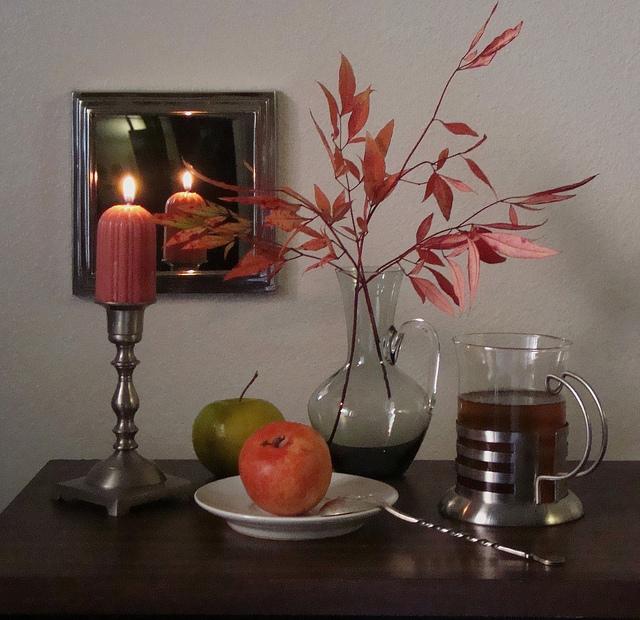What is in the vase?
Be succinct. Flowers. Is the candle lit?
Write a very short answer. Yes. What kind of fruit is on the plate?
Write a very short answer. Apple. What is the color of the flower?
Give a very brief answer. Red. 